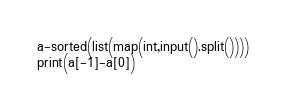Convert code to text. <code><loc_0><loc_0><loc_500><loc_500><_Python_>a-sorted(list(map(int,input().split())))
print(a[-1]-a[0])</code> 